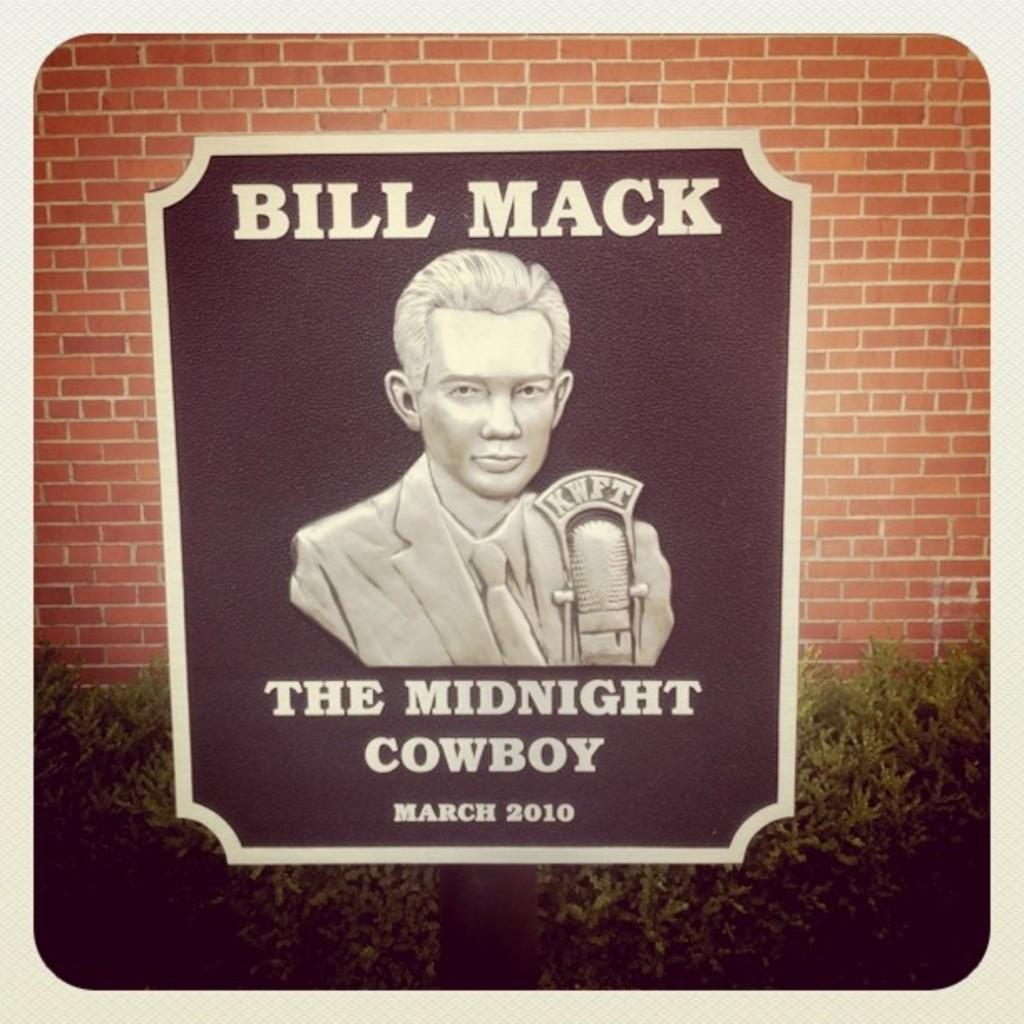What is attached to the pole in the image? There is a board on a pole in the image. What can be seen on the board? Something is written on the board, and there is an image of a person on it. What is visible in the background of the image? There is a wall and plants in the background of the image. What type of weather can be seen in the image? The provided facts do not mention any weather conditions, so it cannot be determined from the image. 